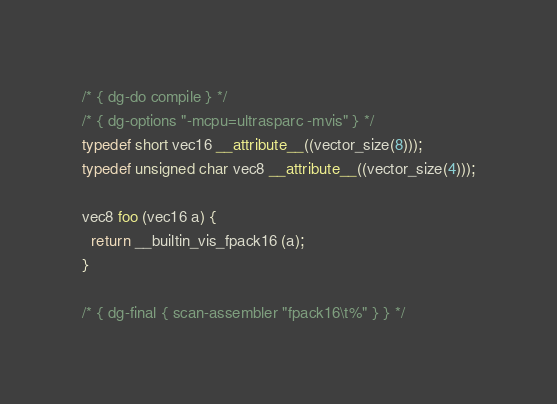<code> <loc_0><loc_0><loc_500><loc_500><_C_>/* { dg-do compile } */
/* { dg-options "-mcpu=ultrasparc -mvis" } */
typedef short vec16 __attribute__((vector_size(8)));
typedef unsigned char vec8 __attribute__((vector_size(4)));

vec8 foo (vec16 a) {
  return __builtin_vis_fpack16 (a);
}

/* { dg-final { scan-assembler "fpack16\t%" } } */
</code> 